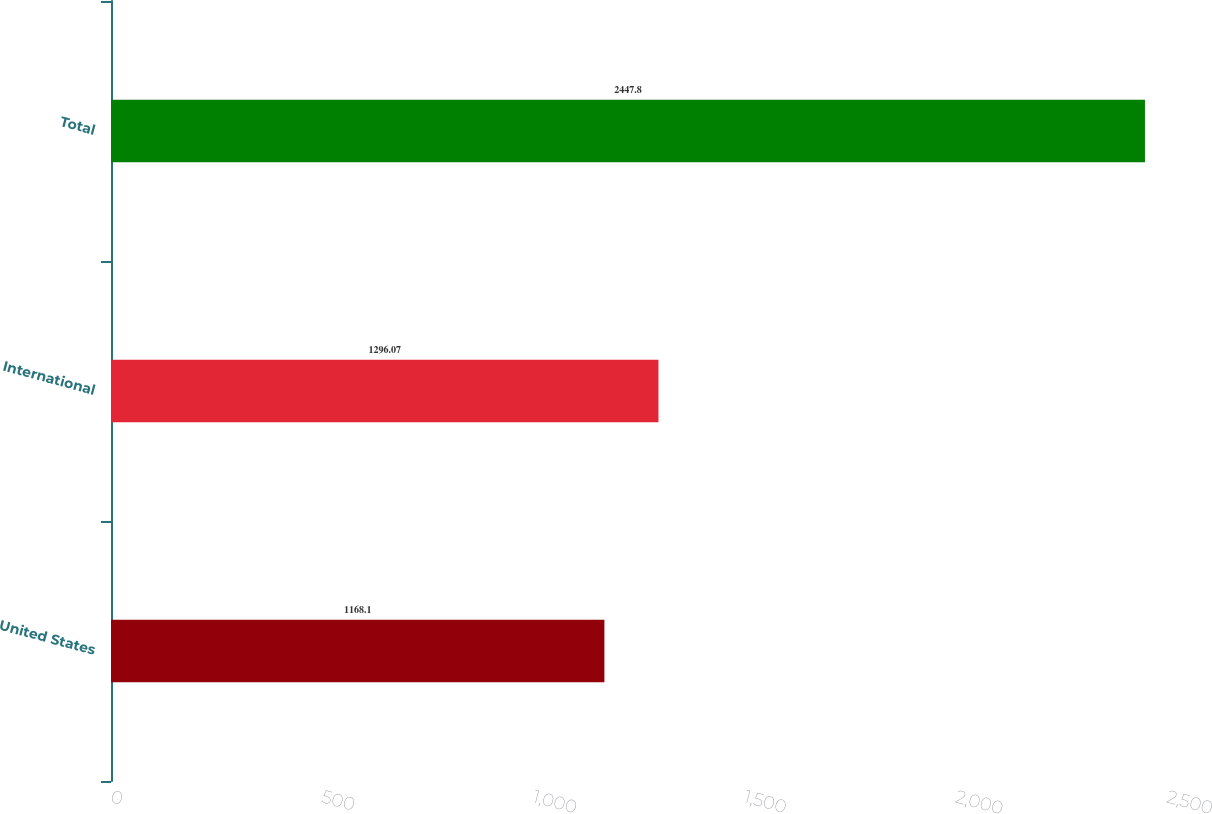<chart> <loc_0><loc_0><loc_500><loc_500><bar_chart><fcel>United States<fcel>International<fcel>Total<nl><fcel>1168.1<fcel>1296.07<fcel>2447.8<nl></chart> 